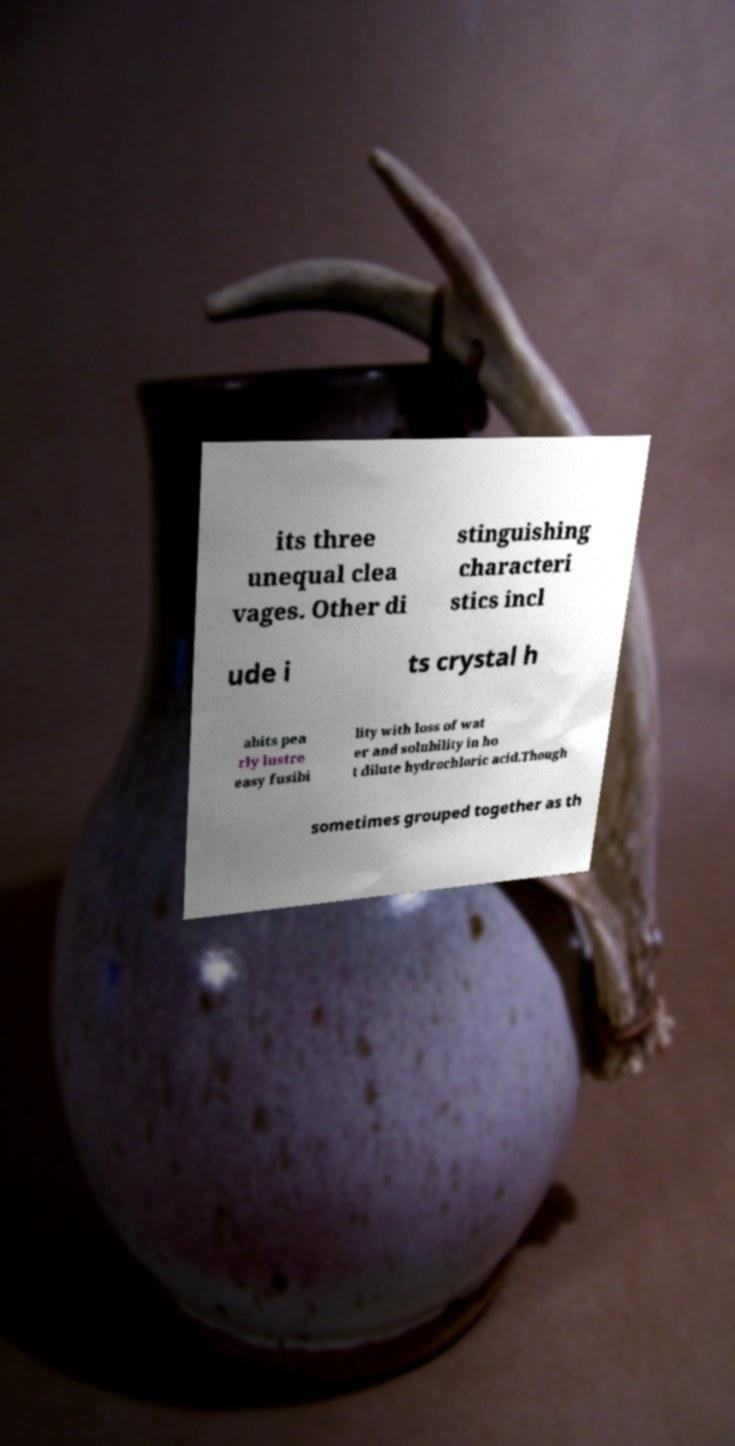Can you read and provide the text displayed in the image?This photo seems to have some interesting text. Can you extract and type it out for me? its three unequal clea vages. Other di stinguishing characteri stics incl ude i ts crystal h abits pea rly lustre easy fusibi lity with loss of wat er and solubility in ho t dilute hydrochloric acid.Though sometimes grouped together as th 